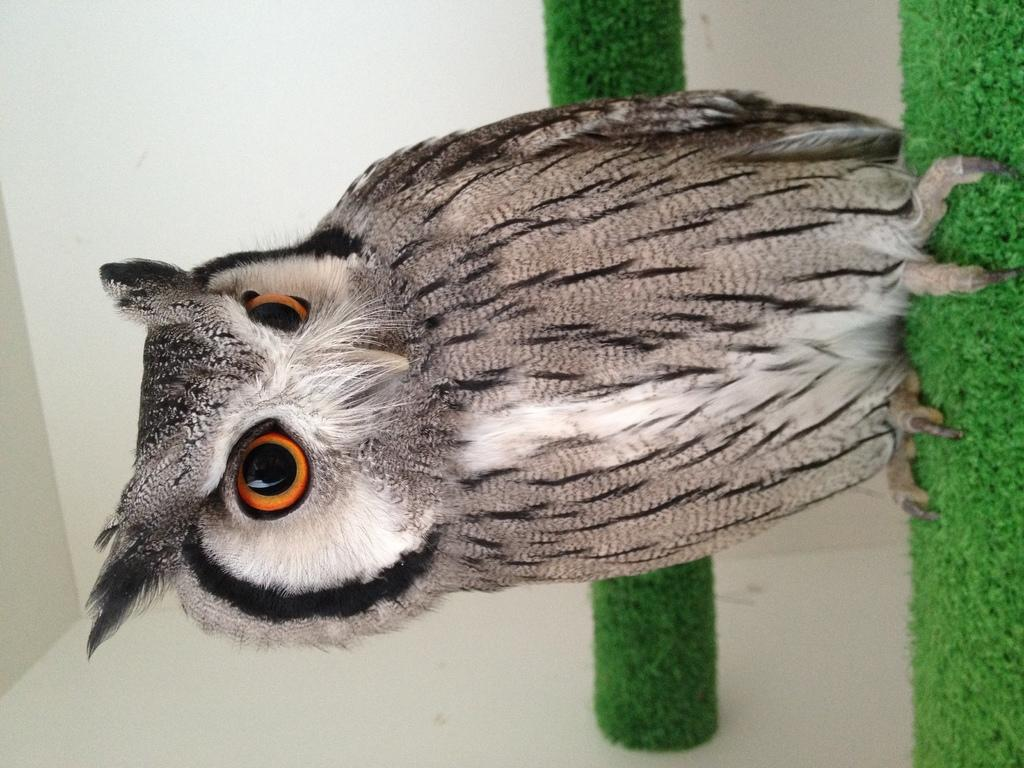What type of animal is in the image? There is an owl in the image. What is the owl sitting on? The owl is on an object. What type of surface is visible in the image? There is artificial grass in the image. What can be seen in the background of the image? There is a wall in the image. What is the owl writing on the wall in the image? The owl is not writing on the wall in the image, as owls do not have the ability to write. 